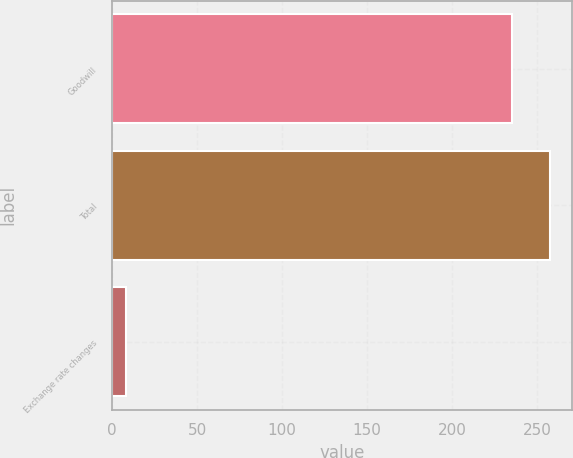Convert chart to OTSL. <chart><loc_0><loc_0><loc_500><loc_500><bar_chart><fcel>Goodwill<fcel>Total<fcel>Exchange rate changes<nl><fcel>235<fcel>257.7<fcel>8<nl></chart> 